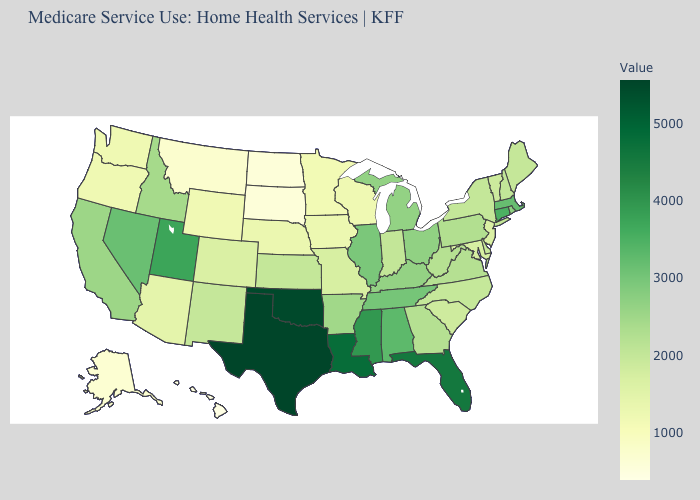Does Hawaii have the lowest value in the USA?
Keep it brief. Yes. Does Montana have a higher value than Delaware?
Be succinct. No. Does Arkansas have the highest value in the USA?
Concise answer only. No. Does New York have a higher value than Iowa?
Write a very short answer. Yes. Among the states that border Missouri , does Iowa have the lowest value?
Give a very brief answer. Yes. 